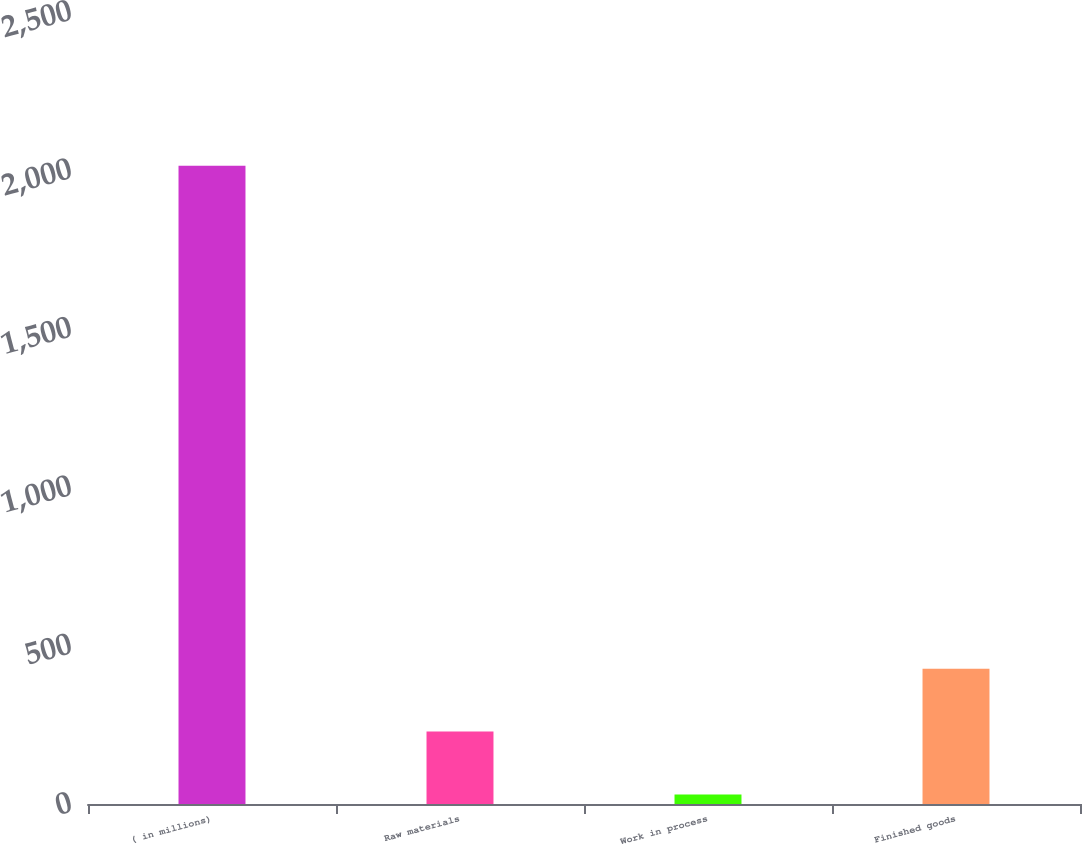Convert chart. <chart><loc_0><loc_0><loc_500><loc_500><bar_chart><fcel>( in millions)<fcel>Raw materials<fcel>Work in process<fcel>Finished goods<nl><fcel>2015<fcel>228.59<fcel>30.1<fcel>427.08<nl></chart> 